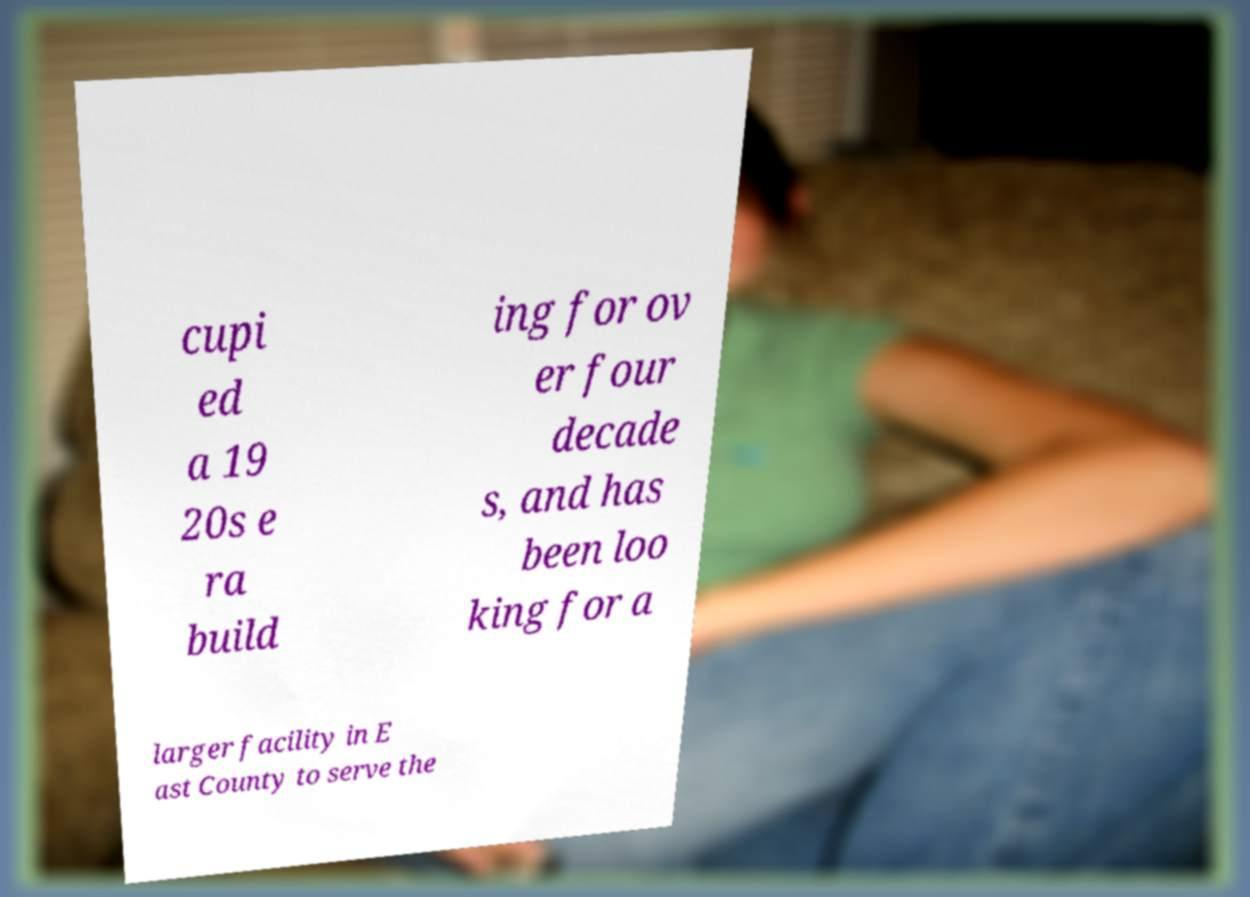Can you read and provide the text displayed in the image?This photo seems to have some interesting text. Can you extract and type it out for me? cupi ed a 19 20s e ra build ing for ov er four decade s, and has been loo king for a larger facility in E ast County to serve the 